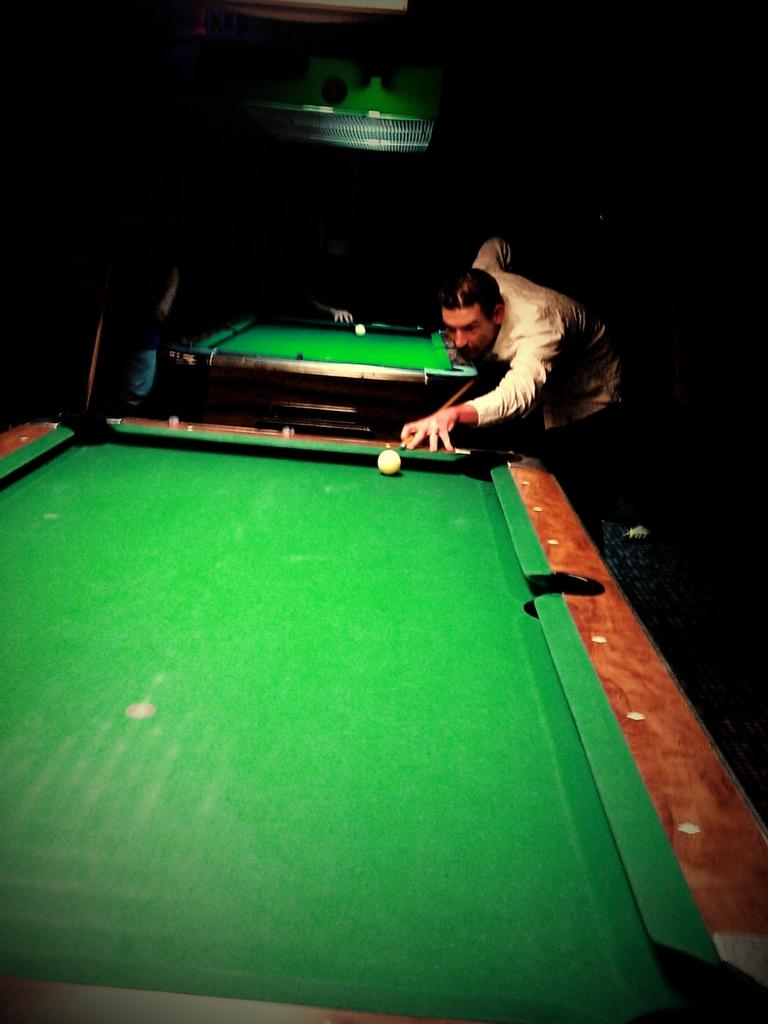What activity is the person on the right side of the image engaged in? The person on the right side of the image is playing billiards on a board. Where are the other two persons in the image located? The two other persons are at the backside of the image. Can you describe the presence of another billiard board in the image? Yes, there is another billiard board visible in the image. What type of mask is the person wearing while playing billiards? There is no mask visible in the image; the person is not wearing any mask while playing billiards. Who is the owner of the crook in the image? There is no crook present in the image; it is a billiards game, not a game involving a crook. 